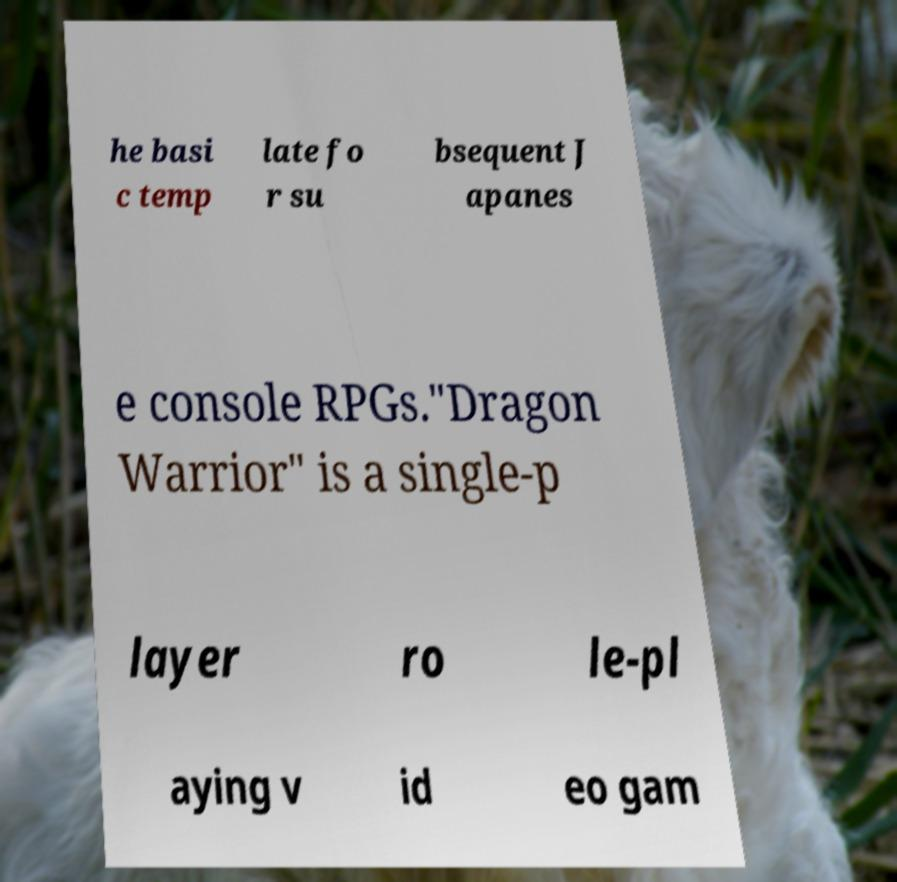Can you read and provide the text displayed in the image?This photo seems to have some interesting text. Can you extract and type it out for me? he basi c temp late fo r su bsequent J apanes e console RPGs."Dragon Warrior" is a single-p layer ro le-pl aying v id eo gam 